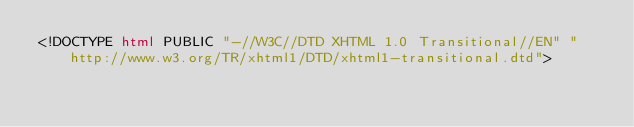Convert code to text. <code><loc_0><loc_0><loc_500><loc_500><_HTML_><!DOCTYPE html PUBLIC "-//W3C//DTD XHTML 1.0 Transitional//EN" "http://www.w3.org/TR/xhtml1/DTD/xhtml1-transitional.dtd"></code> 